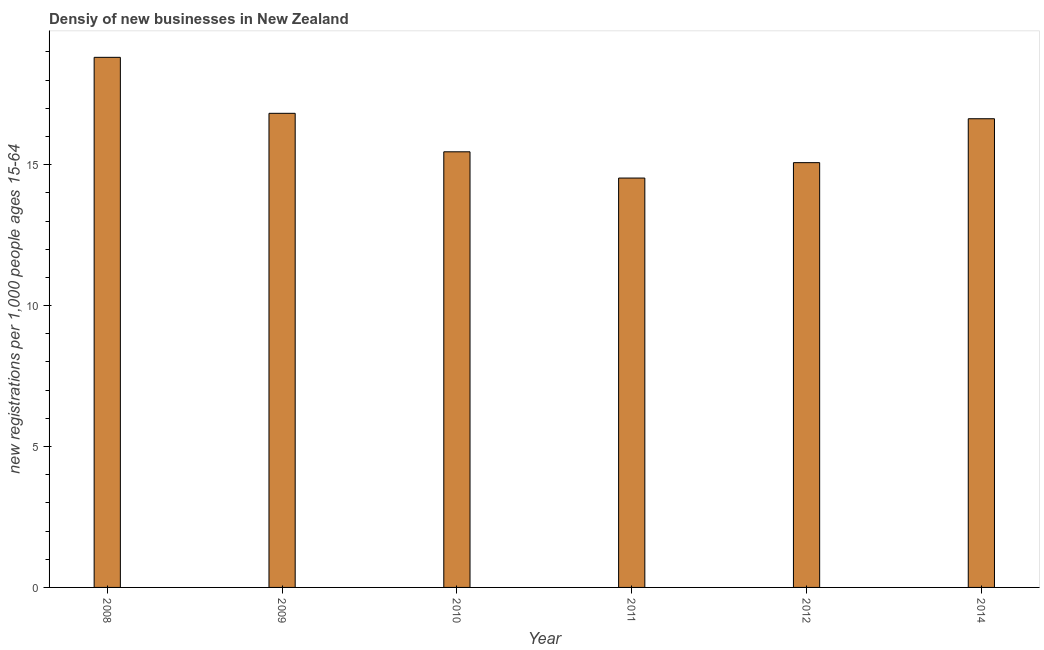Does the graph contain grids?
Provide a succinct answer. No. What is the title of the graph?
Give a very brief answer. Densiy of new businesses in New Zealand. What is the label or title of the X-axis?
Give a very brief answer. Year. What is the label or title of the Y-axis?
Keep it short and to the point. New registrations per 1,0 people ages 15-64. What is the density of new business in 2011?
Provide a short and direct response. 14.53. Across all years, what is the maximum density of new business?
Offer a terse response. 18.81. Across all years, what is the minimum density of new business?
Your answer should be compact. 14.53. In which year was the density of new business maximum?
Provide a succinct answer. 2008. What is the sum of the density of new business?
Provide a short and direct response. 97.31. What is the difference between the density of new business in 2011 and 2014?
Ensure brevity in your answer.  -2.1. What is the average density of new business per year?
Your answer should be very brief. 16.22. What is the median density of new business?
Ensure brevity in your answer.  16.04. In how many years, is the density of new business greater than 7 ?
Your response must be concise. 6. Do a majority of the years between 2014 and 2009 (inclusive) have density of new business greater than 2 ?
Provide a short and direct response. Yes. What is the ratio of the density of new business in 2011 to that in 2014?
Make the answer very short. 0.87. Is the difference between the density of new business in 2008 and 2009 greater than the difference between any two years?
Offer a very short reply. No. What is the difference between the highest and the second highest density of new business?
Provide a short and direct response. 1.99. What is the difference between the highest and the lowest density of new business?
Make the answer very short. 4.28. How many bars are there?
Offer a very short reply. 6. Are all the bars in the graph horizontal?
Your response must be concise. No. How many years are there in the graph?
Ensure brevity in your answer.  6. What is the difference between two consecutive major ticks on the Y-axis?
Offer a terse response. 5. What is the new registrations per 1,000 people ages 15-64 in 2008?
Your answer should be compact. 18.81. What is the new registrations per 1,000 people ages 15-64 of 2009?
Provide a succinct answer. 16.82. What is the new registrations per 1,000 people ages 15-64 of 2010?
Provide a short and direct response. 15.46. What is the new registrations per 1,000 people ages 15-64 of 2011?
Provide a short and direct response. 14.53. What is the new registrations per 1,000 people ages 15-64 in 2012?
Your answer should be compact. 15.07. What is the new registrations per 1,000 people ages 15-64 in 2014?
Keep it short and to the point. 16.63. What is the difference between the new registrations per 1,000 people ages 15-64 in 2008 and 2009?
Make the answer very short. 1.99. What is the difference between the new registrations per 1,000 people ages 15-64 in 2008 and 2010?
Ensure brevity in your answer.  3.35. What is the difference between the new registrations per 1,000 people ages 15-64 in 2008 and 2011?
Give a very brief answer. 4.28. What is the difference between the new registrations per 1,000 people ages 15-64 in 2008 and 2012?
Offer a terse response. 3.74. What is the difference between the new registrations per 1,000 people ages 15-64 in 2008 and 2014?
Your answer should be very brief. 2.18. What is the difference between the new registrations per 1,000 people ages 15-64 in 2009 and 2010?
Give a very brief answer. 1.37. What is the difference between the new registrations per 1,000 people ages 15-64 in 2009 and 2011?
Provide a succinct answer. 2.3. What is the difference between the new registrations per 1,000 people ages 15-64 in 2009 and 2012?
Ensure brevity in your answer.  1.75. What is the difference between the new registrations per 1,000 people ages 15-64 in 2009 and 2014?
Keep it short and to the point. 0.19. What is the difference between the new registrations per 1,000 people ages 15-64 in 2010 and 2011?
Your answer should be very brief. 0.93. What is the difference between the new registrations per 1,000 people ages 15-64 in 2010 and 2012?
Offer a terse response. 0.38. What is the difference between the new registrations per 1,000 people ages 15-64 in 2010 and 2014?
Offer a very short reply. -1.17. What is the difference between the new registrations per 1,000 people ages 15-64 in 2011 and 2012?
Keep it short and to the point. -0.55. What is the difference between the new registrations per 1,000 people ages 15-64 in 2011 and 2014?
Offer a terse response. -2.1. What is the difference between the new registrations per 1,000 people ages 15-64 in 2012 and 2014?
Give a very brief answer. -1.56. What is the ratio of the new registrations per 1,000 people ages 15-64 in 2008 to that in 2009?
Provide a short and direct response. 1.12. What is the ratio of the new registrations per 1,000 people ages 15-64 in 2008 to that in 2010?
Provide a short and direct response. 1.22. What is the ratio of the new registrations per 1,000 people ages 15-64 in 2008 to that in 2011?
Give a very brief answer. 1.29. What is the ratio of the new registrations per 1,000 people ages 15-64 in 2008 to that in 2012?
Your answer should be compact. 1.25. What is the ratio of the new registrations per 1,000 people ages 15-64 in 2008 to that in 2014?
Ensure brevity in your answer.  1.13. What is the ratio of the new registrations per 1,000 people ages 15-64 in 2009 to that in 2010?
Offer a very short reply. 1.09. What is the ratio of the new registrations per 1,000 people ages 15-64 in 2009 to that in 2011?
Make the answer very short. 1.16. What is the ratio of the new registrations per 1,000 people ages 15-64 in 2009 to that in 2012?
Offer a terse response. 1.12. What is the ratio of the new registrations per 1,000 people ages 15-64 in 2009 to that in 2014?
Offer a terse response. 1.01. What is the ratio of the new registrations per 1,000 people ages 15-64 in 2010 to that in 2011?
Keep it short and to the point. 1.06. What is the ratio of the new registrations per 1,000 people ages 15-64 in 2010 to that in 2014?
Your answer should be very brief. 0.93. What is the ratio of the new registrations per 1,000 people ages 15-64 in 2011 to that in 2014?
Your response must be concise. 0.87. What is the ratio of the new registrations per 1,000 people ages 15-64 in 2012 to that in 2014?
Make the answer very short. 0.91. 